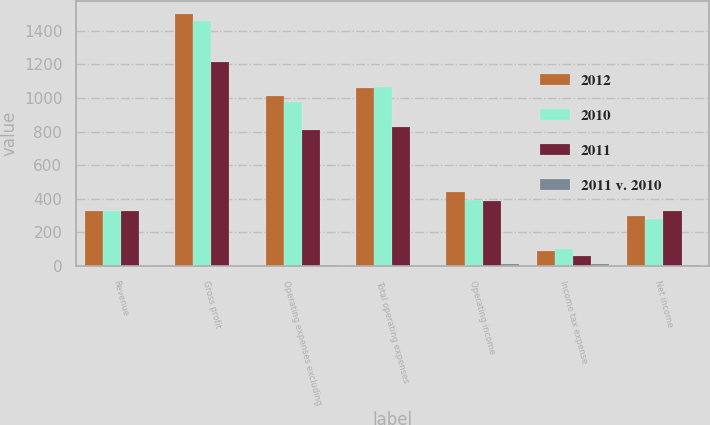Convert chart to OTSL. <chart><loc_0><loc_0><loc_500><loc_500><stacked_bar_chart><ecel><fcel>Revenue<fcel>Gross profit<fcel>Operating expenses excluding<fcel>Total operating expenses<fcel>Operating income<fcel>Income tax expense<fcel>Net income<nl><fcel>2012<fcel>329<fcel>1502<fcel>1013<fcel>1059<fcel>443<fcel>91<fcel>297<nl><fcel>2010<fcel>329<fcel>1461<fcel>979<fcel>1066<fcel>395<fcel>104<fcel>279<nl><fcel>2011<fcel>329<fcel>1214<fcel>811<fcel>826<fcel>388<fcel>59<fcel>329<nl><fcel>2011 v. 2010<fcel>0.3<fcel>2.8<fcel>3.5<fcel>0.7<fcel>12.2<fcel>12.5<fcel>6.5<nl></chart> 